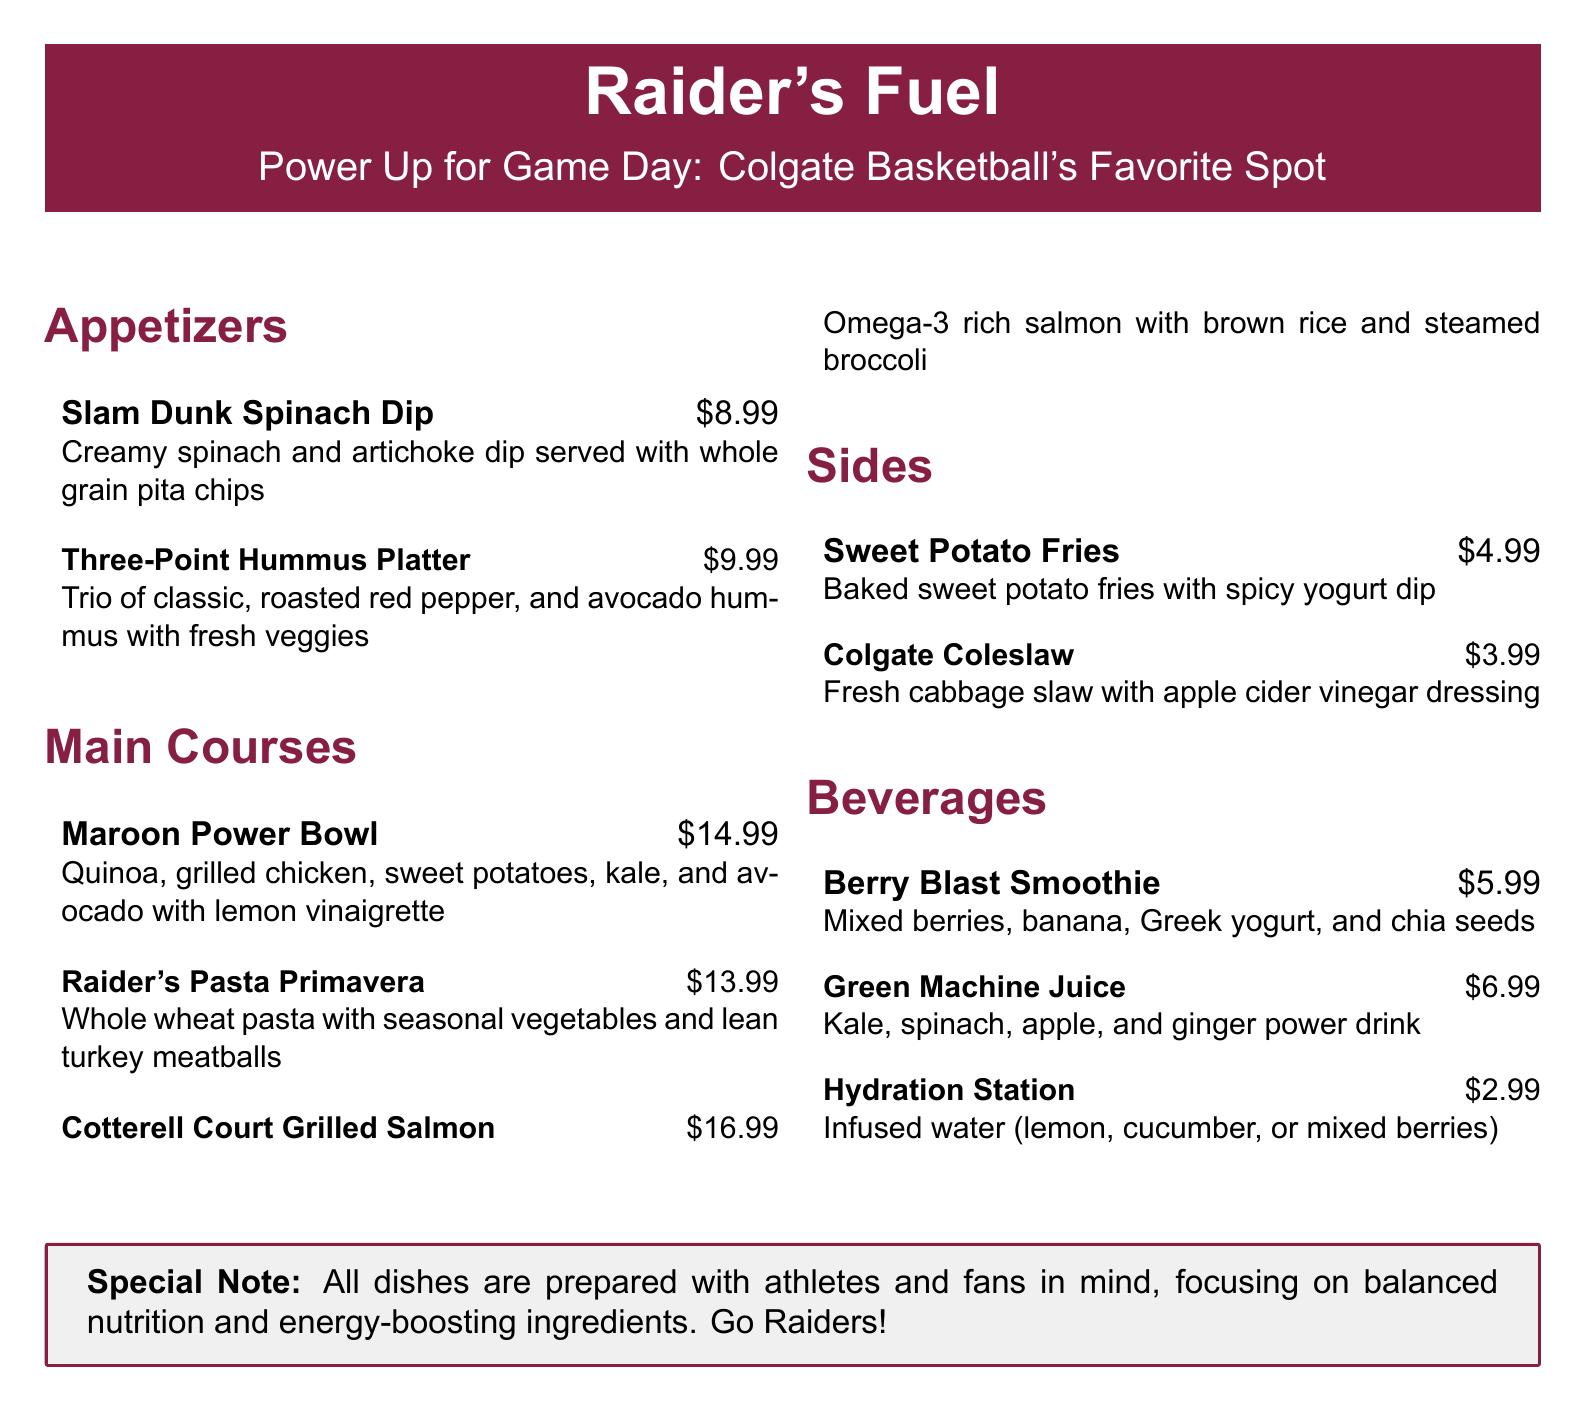What are the main courses available? The main courses listed in the document include the Maroon Power Bowl, Raider's Pasta Primavera, and Cotterell Court Grilled Salmon.
Answer: Maroon Power Bowl, Raider's Pasta Primavera, Cotterell Court Grilled Salmon How much is the Berry Blast Smoothie? The price for the Berry Blast Smoothie is explicitly mentioned in the menu.
Answer: $5.99 What is a key ingredient in the Cotterell Court Grilled Salmon dish? The document highlights that the Cotterell Court Grilled Salmon is omega-3 rich, indicating a key nutritional benefit.
Answer: Omega-3 What type of pasta is used in the Raider's Pasta Primavera? The menu indicates that whole wheat pasta is used in the Raider's Pasta Primavera dish.
Answer: Whole wheat Which side dish has a spicy yogurt dip? The menu specifies that the Sweet Potato Fries come with a spicy yogurt dip.
Answer: Sweet Potato Fries What beverage is designed to be infused water? The Hydration Station is specifically mentioned as the infused water option on the menu.
Answer: Hydration Station How many types of hummus are featured in the Three-Point Hummus Platter? The menu indicates that there are three types of hummus served with the platter.
Answer: Three What is the total price for a Maroon Power Bowl and Sweet Potato Fries? Adding the prices of Maroon Power Bowl ($14.99) and Sweet Potato Fries ($4.99) gives the total amount.
Answer: $19.98 What section do the beverages belong to? The beverages are categorized under their own section explicitly labeled as "Beverages" in the menu.
Answer: Beverages 